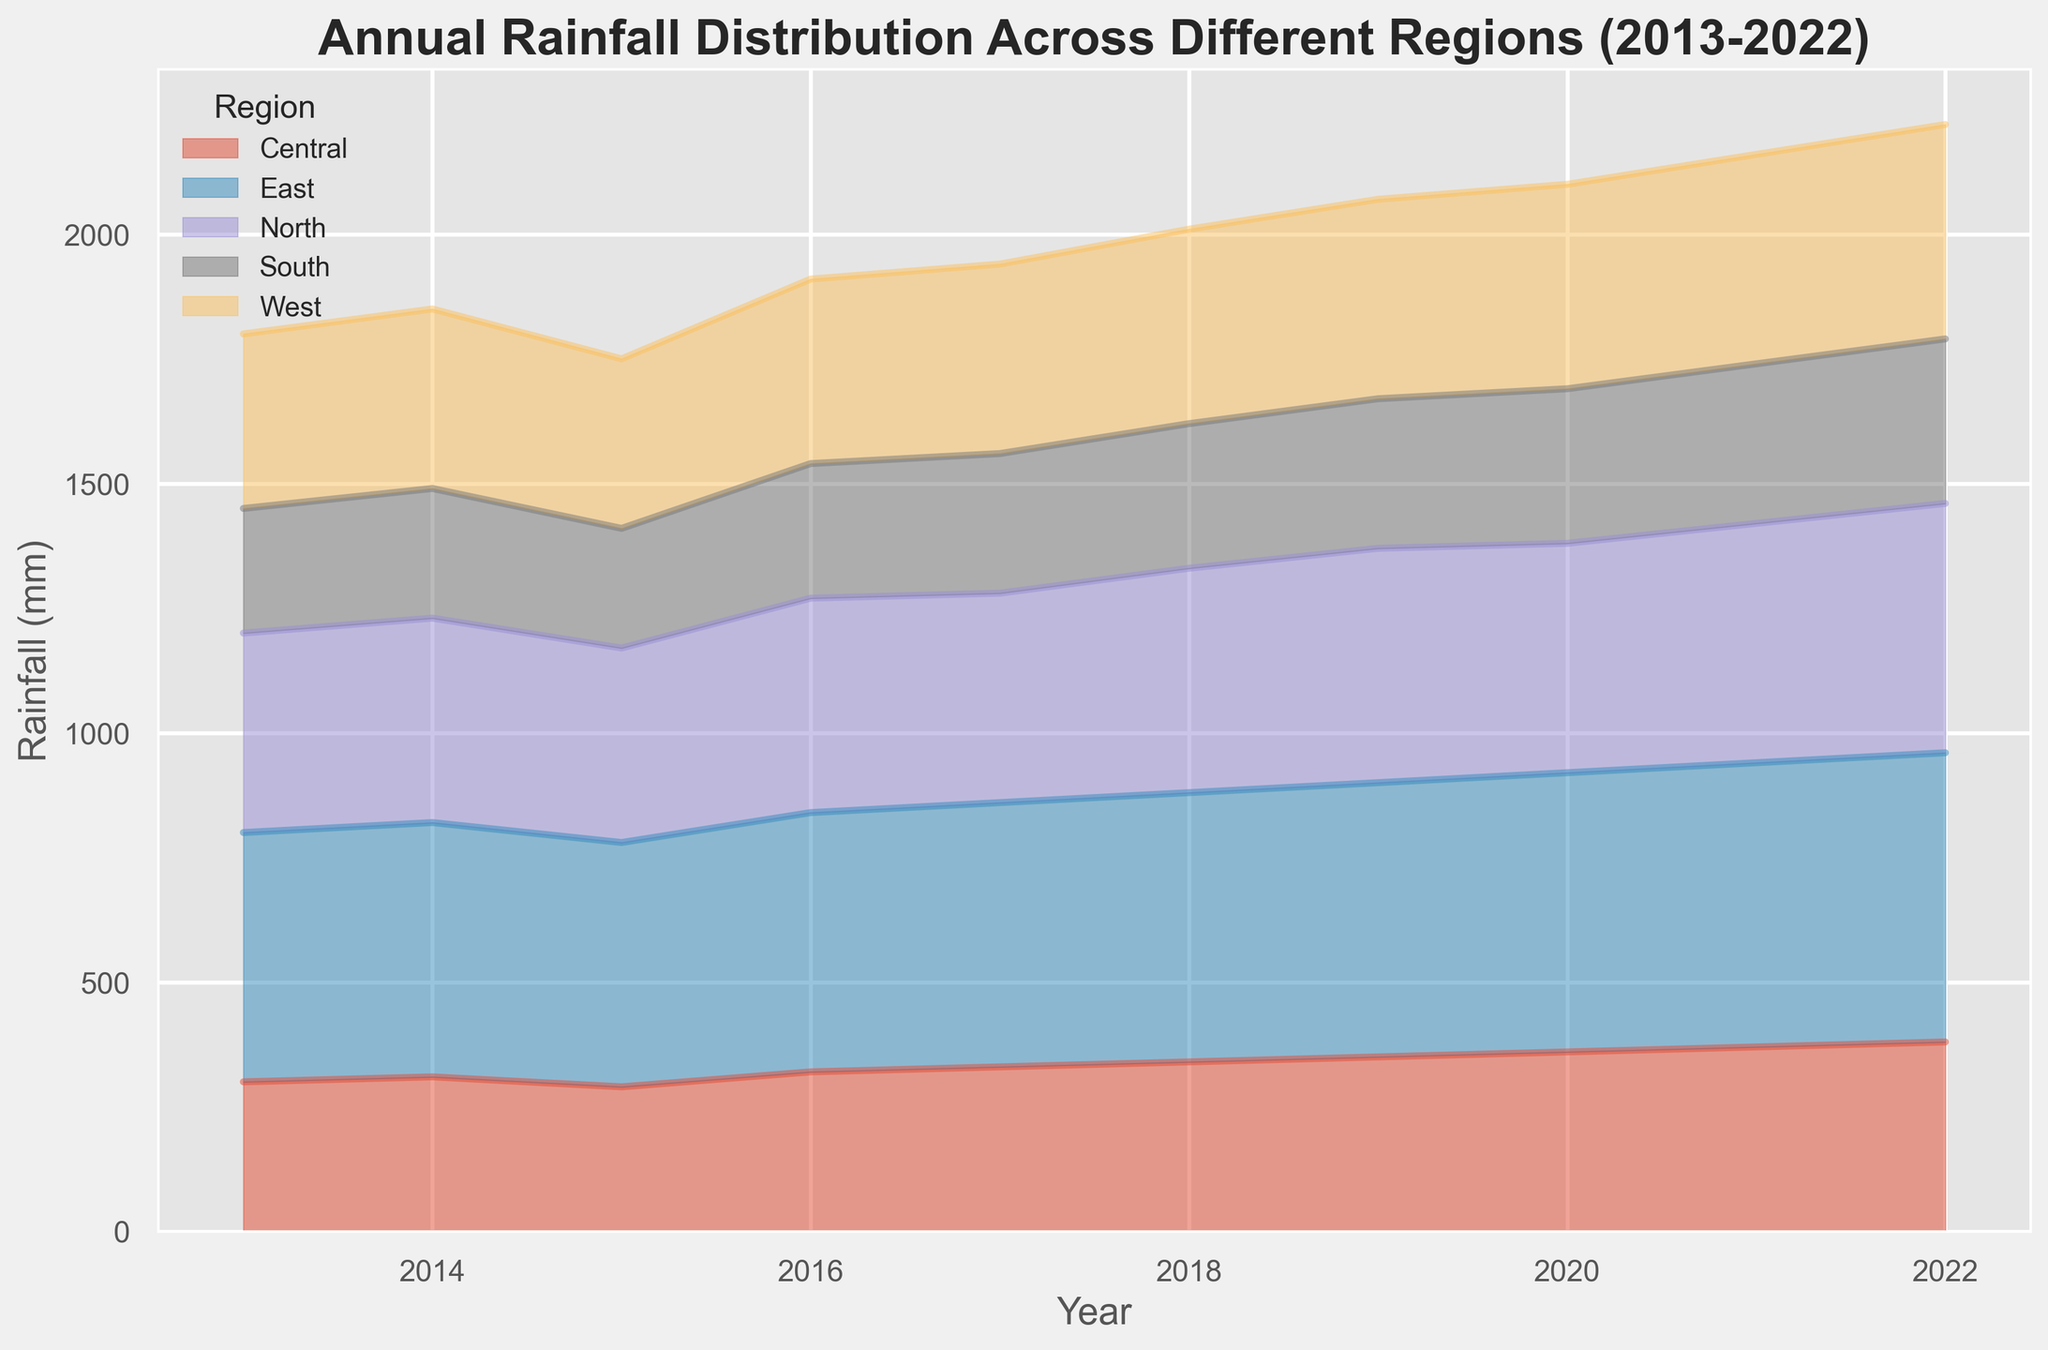What is the trend in rainfall for the East region? The rainfall in the East region shows an increasing trend over the period 2013-2022. Starting at 500mm in 2013, it rises steadily each year, reaching 580mm by 2022.
Answer: Increasing Which region had the highest rainfall in 2022? To determine the region with the highest rainfall in 2022, observe the height of the area segments for that year. The East region has the tallest segment, indicating the highest rainfall at 580mm.
Answer: East Compare the rainfall between the North and South regions in 2016. In 2016, the North region has a rainfall of 430mm, while the South region has 270mm. Comparing these values, the North region received more rainfall.
Answer: North What is the total rainfall across all regions in 2015? To find the total rainfall in 2015, sum the rainfall amounts for all regions in that year. The values are North: 390mm, Central: 290mm, South: 240mm, East: 490mm, West: 340mm. Summing these gives 390 + 290 + 240 + 490 + 340 = 1750mm.
Answer: 1750mm How did the rainfall in the West region change from 2013 to 2022? The rainfall in the West region increased from 350mm in 2013 to 430mm in 2022. It shows a gradual upward trend over these years.
Answer: Increased Which region showed the most consistent rainfall over the given decade? Consistency can be observed by looking for regions with relatively stable and less fluctuating area segments over the years. The Central region displays the most consistent rainfall, with values gradually increasing from 300mm in 2013 to 380mm in 2022 without significant fluctuations.
Answer: Central What is the difference in rainfall between the East and North regions in 2019? In 2019, the rainfall for the East region is 550mm and for the North region is 470mm. The difference is 550 - 470 = 80mm.
Answer: 80mm Which region experienced the least rainfall consistently over the years? Observing the lowest area segments over the decade, the South region consistently shows the lowest rainfall amounts compared to other regions each year.
Answer: South 